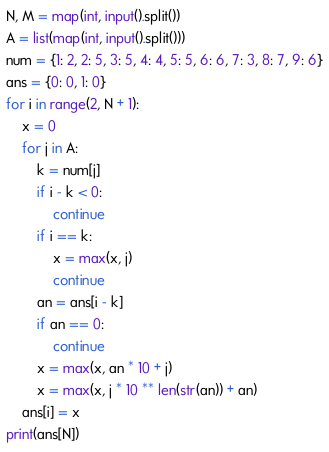<code> <loc_0><loc_0><loc_500><loc_500><_Python_>N, M = map(int, input().split())
A = list(map(int, input().split()))
num = {1: 2, 2: 5, 3: 5, 4: 4, 5: 5, 6: 6, 7: 3, 8: 7, 9: 6}
ans = {0: 0, 1: 0}
for i in range(2, N + 1):
    x = 0
    for j in A:
        k = num[j]
        if i - k < 0:
            continue
        if i == k:
            x = max(x, j)
            continue
        an = ans[i - k]
        if an == 0:
            continue
        x = max(x, an * 10 + j)
        x = max(x, j * 10 ** len(str(an)) + an)
    ans[i] = x
print(ans[N])</code> 